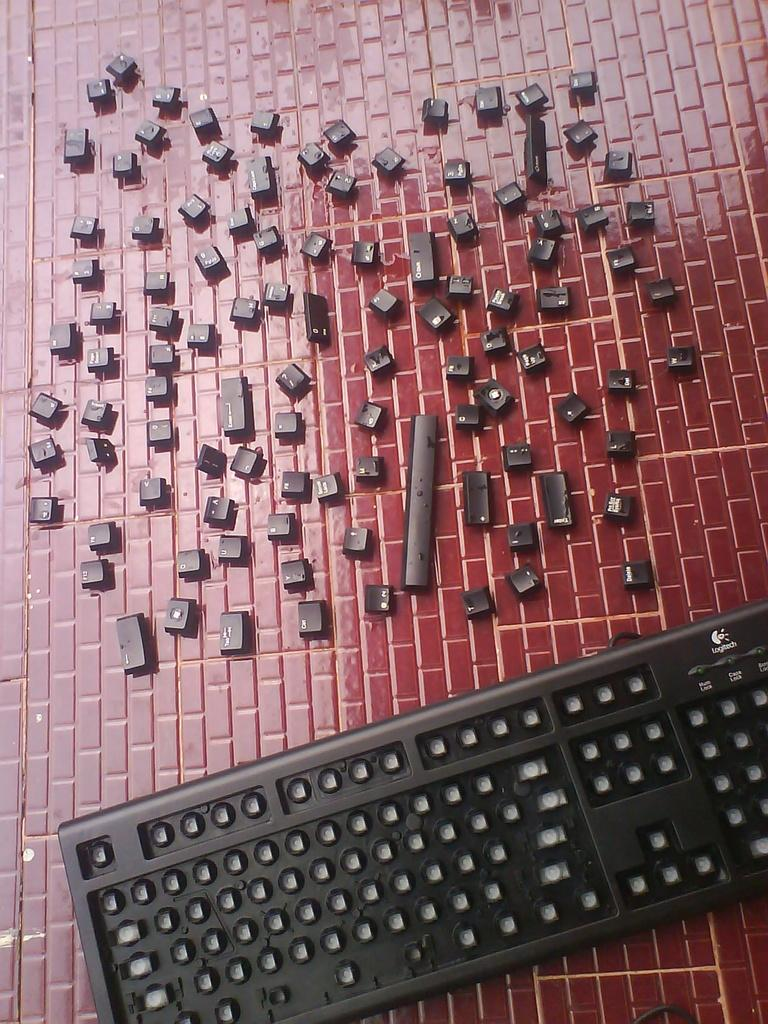What type of device is shown in the image? There is a keyboard in the image. What part of the keyboard is visible? The keyboard keys are visible on the object. What type of bait is being used to catch fish in the image? There is no bait or fish present in the image; it only features a keyboard. 